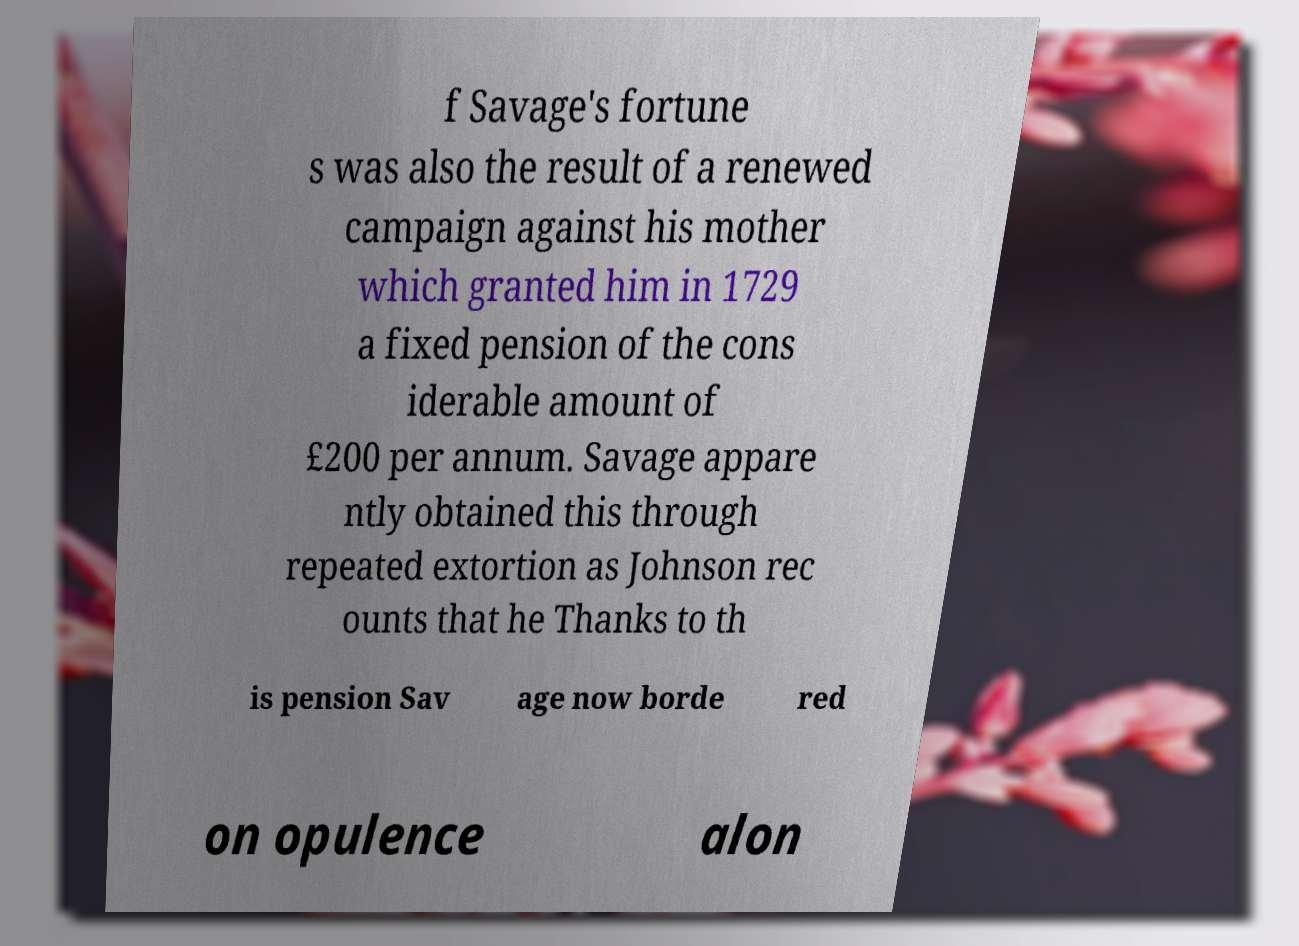For documentation purposes, I need the text within this image transcribed. Could you provide that? f Savage's fortune s was also the result of a renewed campaign against his mother which granted him in 1729 a fixed pension of the cons iderable amount of £200 per annum. Savage appare ntly obtained this through repeated extortion as Johnson rec ounts that he Thanks to th is pension Sav age now borde red on opulence alon 